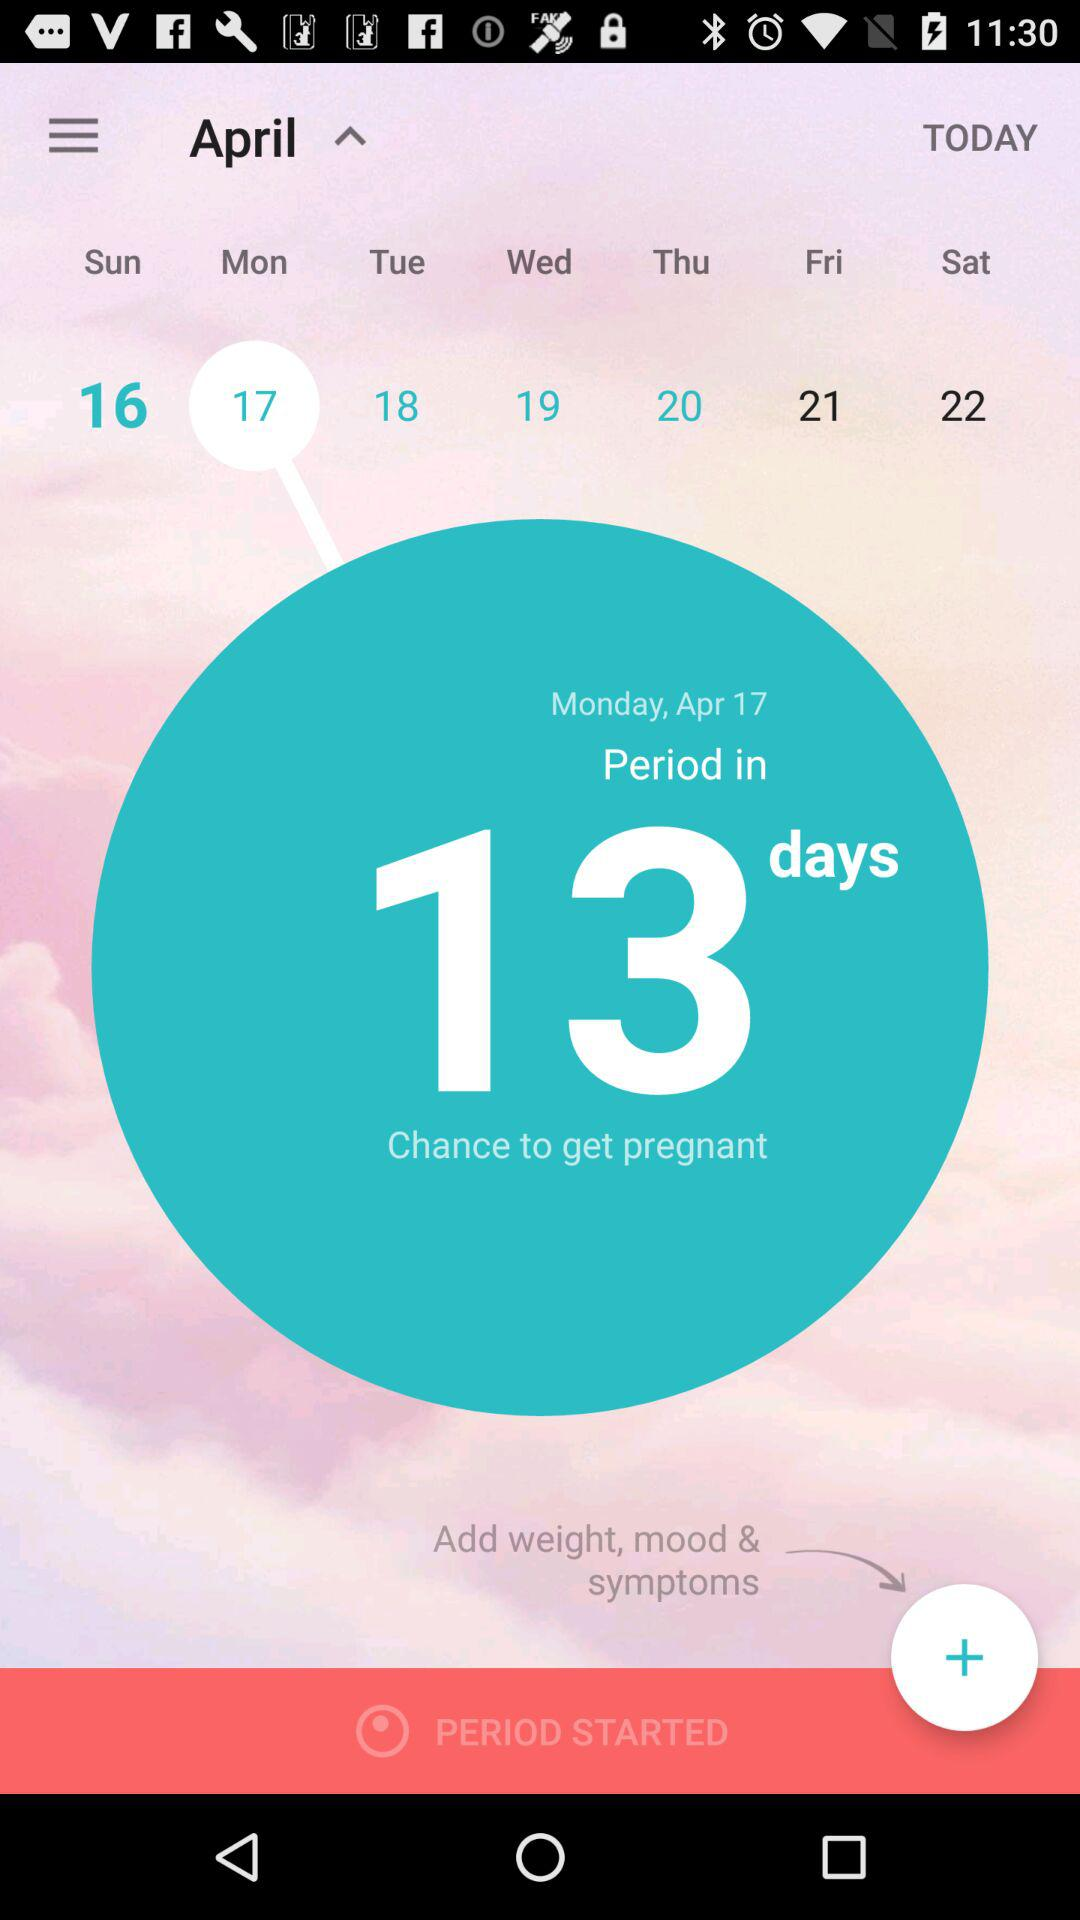What is the month? The month is April. 